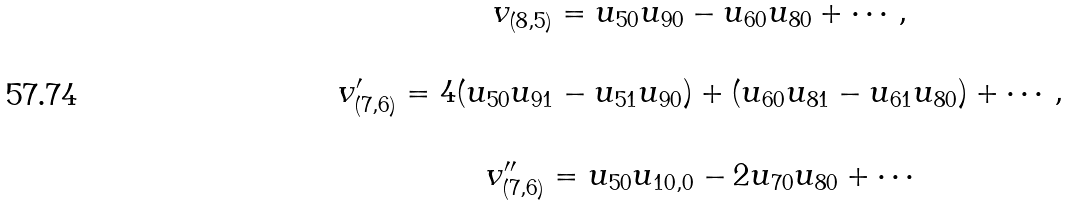Convert formula to latex. <formula><loc_0><loc_0><loc_500><loc_500>\begin{array} { c } v _ { ( 8 , 5 ) } = u _ { 5 0 } u _ { 9 0 } - u _ { 6 0 } u _ { 8 0 } + \cdots , \\ \\ v ^ { \prime } _ { ( 7 , 6 ) } = 4 ( u _ { 5 0 } u _ { 9 1 } - u _ { 5 1 } u _ { 9 0 } ) + ( u _ { 6 0 } u _ { 8 1 } - u _ { 6 1 } u _ { 8 0 } ) + \cdots , \\ \\ v ^ { \prime \prime } _ { ( 7 , 6 ) } = u _ { 5 0 } u _ { 1 0 , 0 } - 2 u _ { 7 0 } u _ { 8 0 } + \cdots \\ \end{array}</formula> 